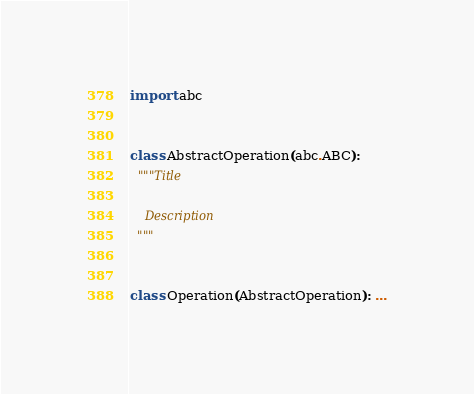<code> <loc_0><loc_0><loc_500><loc_500><_Python_>
import abc


class AbstractOperation(abc.ABC):
  """Title

    Description
  """


class Operation(AbstractOperation): ...

</code> 